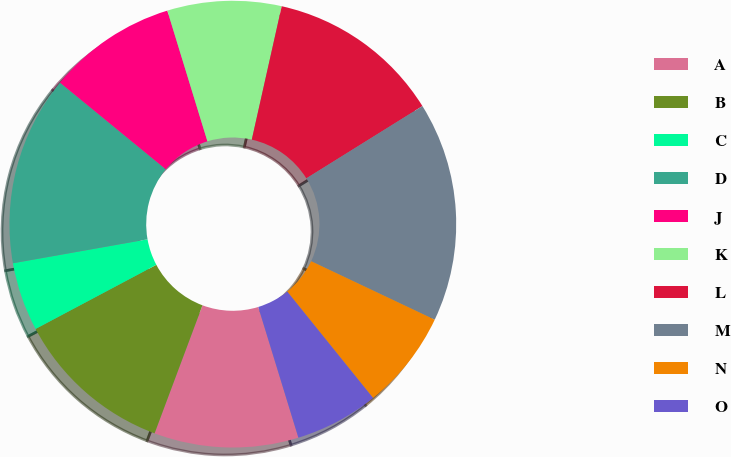Convert chart. <chart><loc_0><loc_0><loc_500><loc_500><pie_chart><fcel>A<fcel>B<fcel>C<fcel>D<fcel>J<fcel>K<fcel>L<fcel>M<fcel>N<fcel>O<nl><fcel>10.44%<fcel>11.53%<fcel>4.97%<fcel>13.72%<fcel>9.34%<fcel>8.25%<fcel>12.62%<fcel>15.9%<fcel>7.16%<fcel>6.06%<nl></chart> 